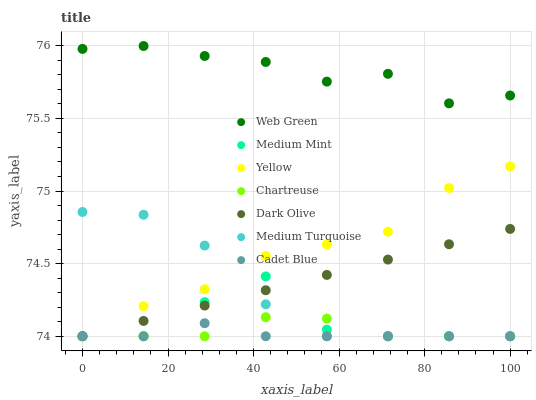Does Cadet Blue have the minimum area under the curve?
Answer yes or no. Yes. Does Web Green have the maximum area under the curve?
Answer yes or no. Yes. Does Dark Olive have the minimum area under the curve?
Answer yes or no. No. Does Dark Olive have the maximum area under the curve?
Answer yes or no. No. Is Dark Olive the smoothest?
Answer yes or no. Yes. Is Medium Mint the roughest?
Answer yes or no. Yes. Is Cadet Blue the smoothest?
Answer yes or no. No. Is Cadet Blue the roughest?
Answer yes or no. No. Does Medium Mint have the lowest value?
Answer yes or no. Yes. Does Web Green have the lowest value?
Answer yes or no. No. Does Web Green have the highest value?
Answer yes or no. Yes. Does Dark Olive have the highest value?
Answer yes or no. No. Is Cadet Blue less than Web Green?
Answer yes or no. Yes. Is Web Green greater than Medium Mint?
Answer yes or no. Yes. Does Dark Olive intersect Yellow?
Answer yes or no. Yes. Is Dark Olive less than Yellow?
Answer yes or no. No. Is Dark Olive greater than Yellow?
Answer yes or no. No. Does Cadet Blue intersect Web Green?
Answer yes or no. No. 